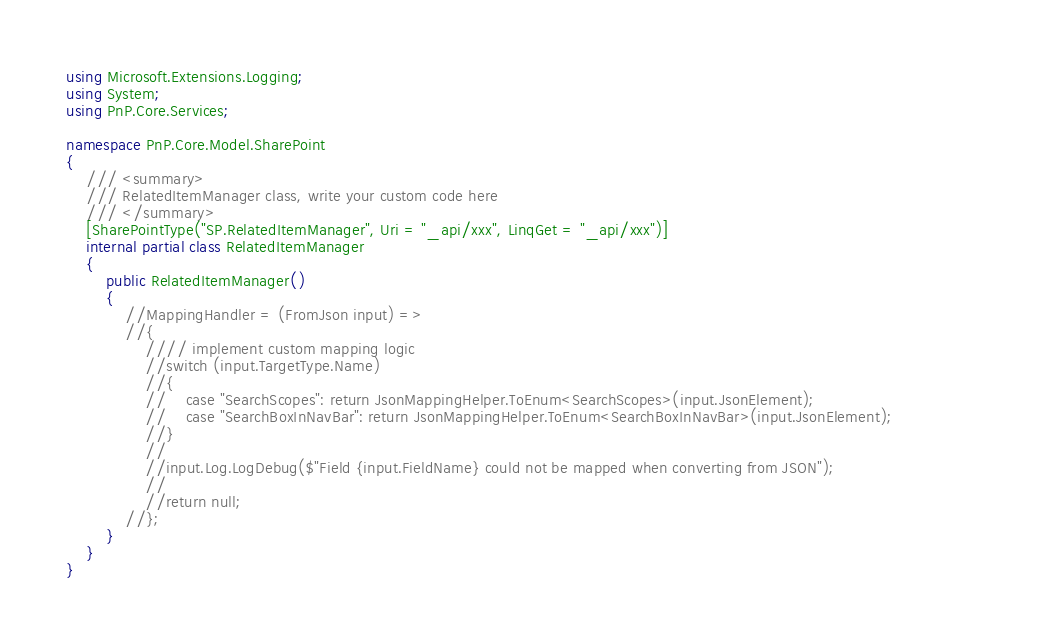Convert code to text. <code><loc_0><loc_0><loc_500><loc_500><_C#_>using Microsoft.Extensions.Logging;
using System;
using PnP.Core.Services;

namespace PnP.Core.Model.SharePoint
{
    /// <summary>
    /// RelatedItemManager class, write your custom code here
    /// </summary>
    [SharePointType("SP.RelatedItemManager", Uri = "_api/xxx", LinqGet = "_api/xxx")]
    internal partial class RelatedItemManager
    {
        public RelatedItemManager()
        {
            //MappingHandler = (FromJson input) =>
            //{
                //// implement custom mapping logic
                //switch (input.TargetType.Name)
                //{
                //    case "SearchScopes": return JsonMappingHelper.ToEnum<SearchScopes>(input.JsonElement);
                //    case "SearchBoxInNavBar": return JsonMappingHelper.ToEnum<SearchBoxInNavBar>(input.JsonElement);                    
                //}
                //
                //input.Log.LogDebug($"Field {input.FieldName} could not be mapped when converting from JSON");
                //
                //return null;
            //};
        }
    }
}
</code> 